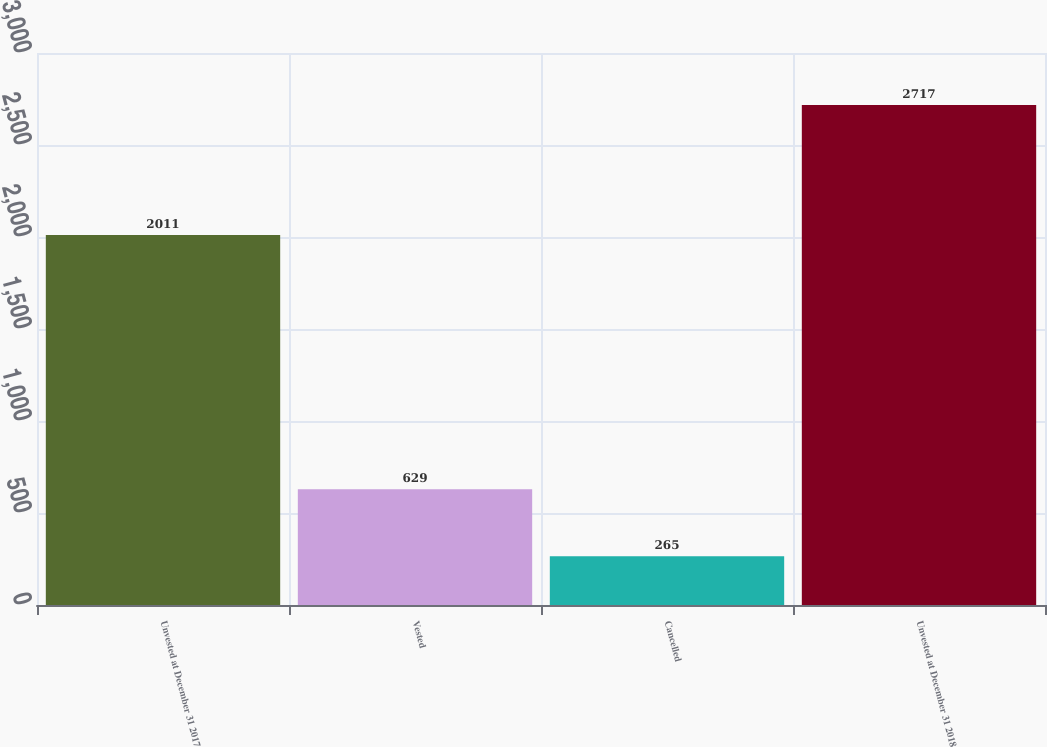<chart> <loc_0><loc_0><loc_500><loc_500><bar_chart><fcel>Unvested at December 31 2017<fcel>Vested<fcel>Cancelled<fcel>Unvested at December 31 2018<nl><fcel>2011<fcel>629<fcel>265<fcel>2717<nl></chart> 